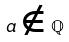Convert formula to latex. <formula><loc_0><loc_0><loc_500><loc_500>a \notin \mathbb { Q }</formula> 